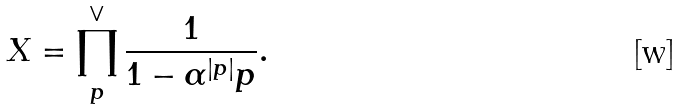<formula> <loc_0><loc_0><loc_500><loc_500>X = \prod _ { p } ^ { \vee } \frac { 1 } { 1 - \alpha ^ { | p | } p } .</formula> 